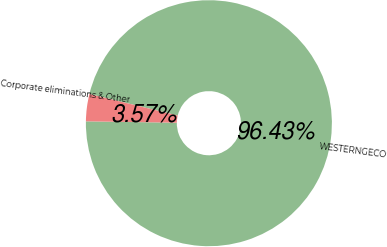Convert chart. <chart><loc_0><loc_0><loc_500><loc_500><pie_chart><fcel>WESTERNGECO<fcel>Corporate eliminations & Other<nl><fcel>96.43%<fcel>3.57%<nl></chart> 